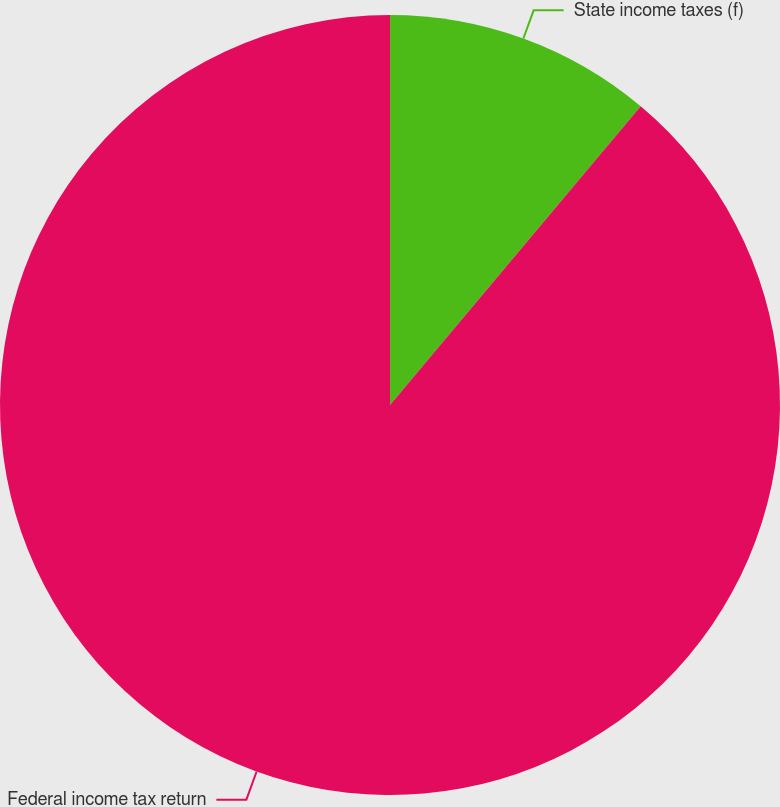<chart> <loc_0><loc_0><loc_500><loc_500><pie_chart><fcel>State income taxes (f)<fcel>Federal income tax return<nl><fcel>11.11%<fcel>88.89%<nl></chart> 